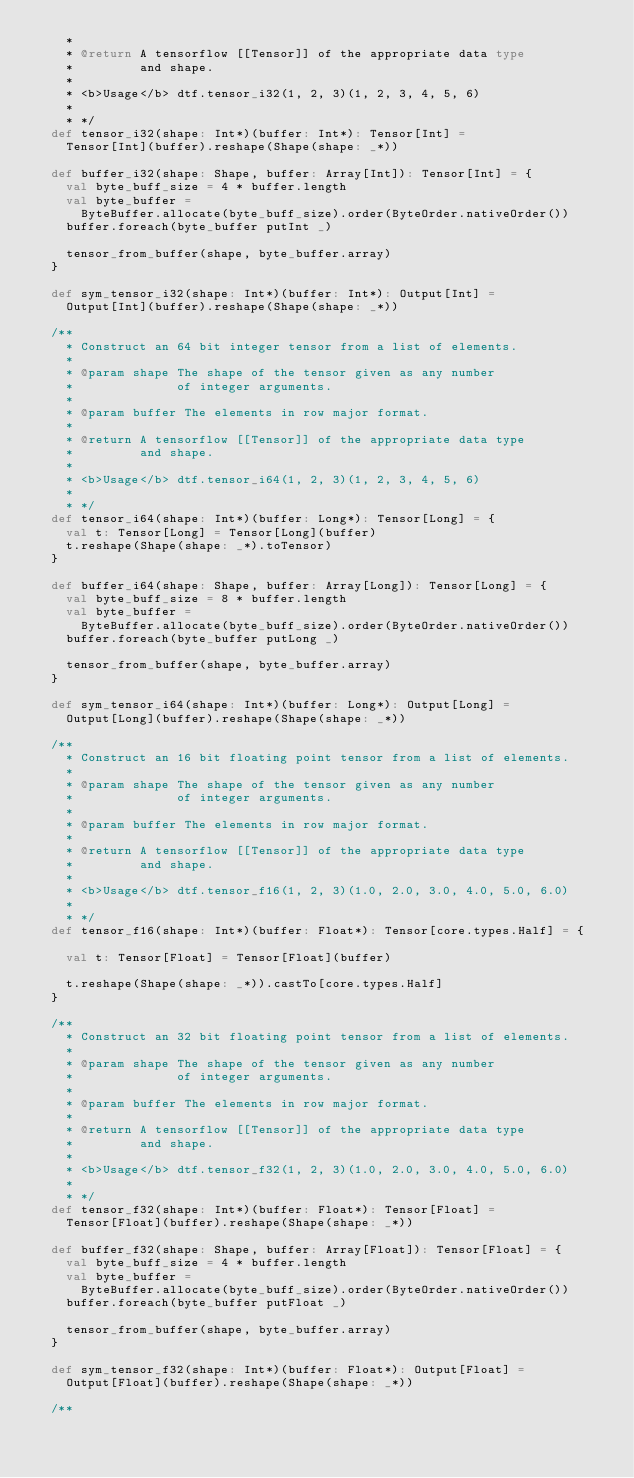Convert code to text. <code><loc_0><loc_0><loc_500><loc_500><_Scala_>    *
    * @return A tensorflow [[Tensor]] of the appropriate data type
    *         and shape.
    *
    * <b>Usage</b> dtf.tensor_i32(1, 2, 3)(1, 2, 3, 4, 5, 6)
    *
    * */
  def tensor_i32(shape: Int*)(buffer: Int*): Tensor[Int] =
    Tensor[Int](buffer).reshape(Shape(shape: _*))

  def buffer_i32(shape: Shape, buffer: Array[Int]): Tensor[Int] = {
    val byte_buff_size = 4 * buffer.length
    val byte_buffer =
      ByteBuffer.allocate(byte_buff_size).order(ByteOrder.nativeOrder())
    buffer.foreach(byte_buffer putInt _)

    tensor_from_buffer(shape, byte_buffer.array)
  }

  def sym_tensor_i32(shape: Int*)(buffer: Int*): Output[Int] =
    Output[Int](buffer).reshape(Shape(shape: _*))

  /**
    * Construct an 64 bit integer tensor from a list of elements.
    *
    * @param shape The shape of the tensor given as any number
    *              of integer arguments.
    *
    * @param buffer The elements in row major format.
    *
    * @return A tensorflow [[Tensor]] of the appropriate data type
    *         and shape.
    *
    * <b>Usage</b> dtf.tensor_i64(1, 2, 3)(1, 2, 3, 4, 5, 6)
    *
    * */
  def tensor_i64(shape: Int*)(buffer: Long*): Tensor[Long] = {
    val t: Tensor[Long] = Tensor[Long](buffer)
    t.reshape(Shape(shape: _*).toTensor)
  }

  def buffer_i64(shape: Shape, buffer: Array[Long]): Tensor[Long] = {
    val byte_buff_size = 8 * buffer.length
    val byte_buffer =
      ByteBuffer.allocate(byte_buff_size).order(ByteOrder.nativeOrder())
    buffer.foreach(byte_buffer putLong _)

    tensor_from_buffer(shape, byte_buffer.array)
  }

  def sym_tensor_i64(shape: Int*)(buffer: Long*): Output[Long] =
    Output[Long](buffer).reshape(Shape(shape: _*))

  /**
    * Construct an 16 bit floating point tensor from a list of elements.
    *
    * @param shape The shape of the tensor given as any number
    *              of integer arguments.
    *
    * @param buffer The elements in row major format.
    *
    * @return A tensorflow [[Tensor]] of the appropriate data type
    *         and shape.
    *
    * <b>Usage</b> dtf.tensor_f16(1, 2, 3)(1.0, 2.0, 3.0, 4.0, 5.0, 6.0)
    *
    * */
  def tensor_f16(shape: Int*)(buffer: Float*): Tensor[core.types.Half] = {

    val t: Tensor[Float] = Tensor[Float](buffer)

    t.reshape(Shape(shape: _*)).castTo[core.types.Half]
  }

  /**
    * Construct an 32 bit floating point tensor from a list of elements.
    *
    * @param shape The shape of the tensor given as any number
    *              of integer arguments.
    *
    * @param buffer The elements in row major format.
    *
    * @return A tensorflow [[Tensor]] of the appropriate data type
    *         and shape.
    *
    * <b>Usage</b> dtf.tensor_f32(1, 2, 3)(1.0, 2.0, 3.0, 4.0, 5.0, 6.0)
    *
    * */
  def tensor_f32(shape: Int*)(buffer: Float*): Tensor[Float] =
    Tensor[Float](buffer).reshape(Shape(shape: _*))

  def buffer_f32(shape: Shape, buffer: Array[Float]): Tensor[Float] = {
    val byte_buff_size = 4 * buffer.length
    val byte_buffer =
      ByteBuffer.allocate(byte_buff_size).order(ByteOrder.nativeOrder())
    buffer.foreach(byte_buffer putFloat _)

    tensor_from_buffer(shape, byte_buffer.array)
  }

  def sym_tensor_f32(shape: Int*)(buffer: Float*): Output[Float] =
    Output[Float](buffer).reshape(Shape(shape: _*))

  /**</code> 